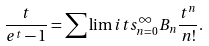<formula> <loc_0><loc_0><loc_500><loc_500>\frac { t } { e ^ { t } - 1 } = \sum \lim i t s _ { n = 0 } ^ { \infty } B _ { n } \frac { t ^ { n } } { n ! } .</formula> 